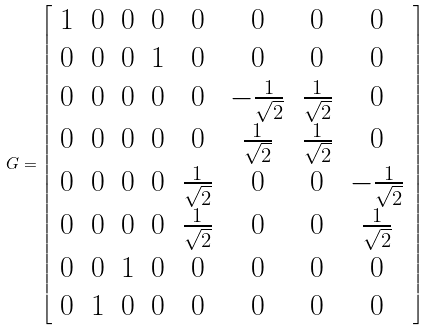<formula> <loc_0><loc_0><loc_500><loc_500>G = \left [ \begin{array} { c c c c c c c c } 1 & 0 & 0 & 0 & 0 & 0 & 0 & 0 \\ 0 & 0 & 0 & 1 & 0 & 0 & 0 & 0 \\ 0 & 0 & 0 & 0 & 0 & - \frac { 1 } { \sqrt { 2 } } & \frac { 1 } { \sqrt { 2 } } & 0 \\ 0 & 0 & 0 & 0 & 0 & \frac { 1 } { \sqrt { 2 } } & \frac { 1 } { \sqrt { 2 } } & 0 \\ 0 & 0 & 0 & 0 & \frac { 1 } { \sqrt { 2 } } & 0 & 0 & - \frac { 1 } { \sqrt { 2 } } \\ 0 & 0 & 0 & 0 & \frac { 1 } { \sqrt { 2 } } & 0 & 0 & \frac { 1 } { \sqrt { 2 } } \\ 0 & 0 & 1 & 0 & 0 & 0 & 0 & 0 \\ 0 & 1 & 0 & 0 & 0 & 0 & 0 & 0 \\ \end{array} \right ]</formula> 